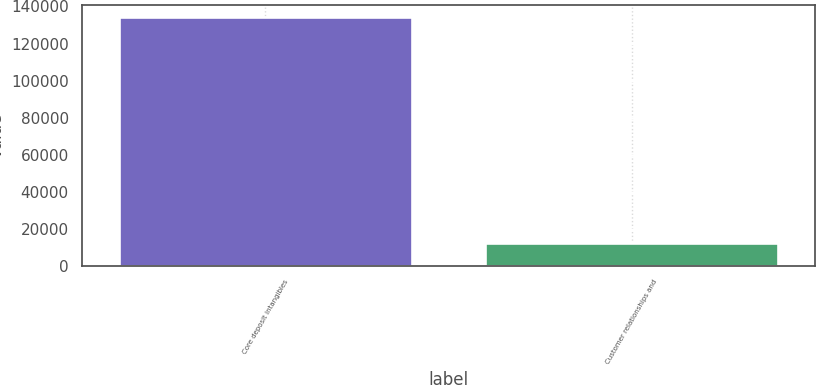Convert chart. <chart><loc_0><loc_0><loc_500><loc_500><bar_chart><fcel>Core deposit intangibles<fcel>Customer relationships and<nl><fcel>134292<fcel>12494<nl></chart> 